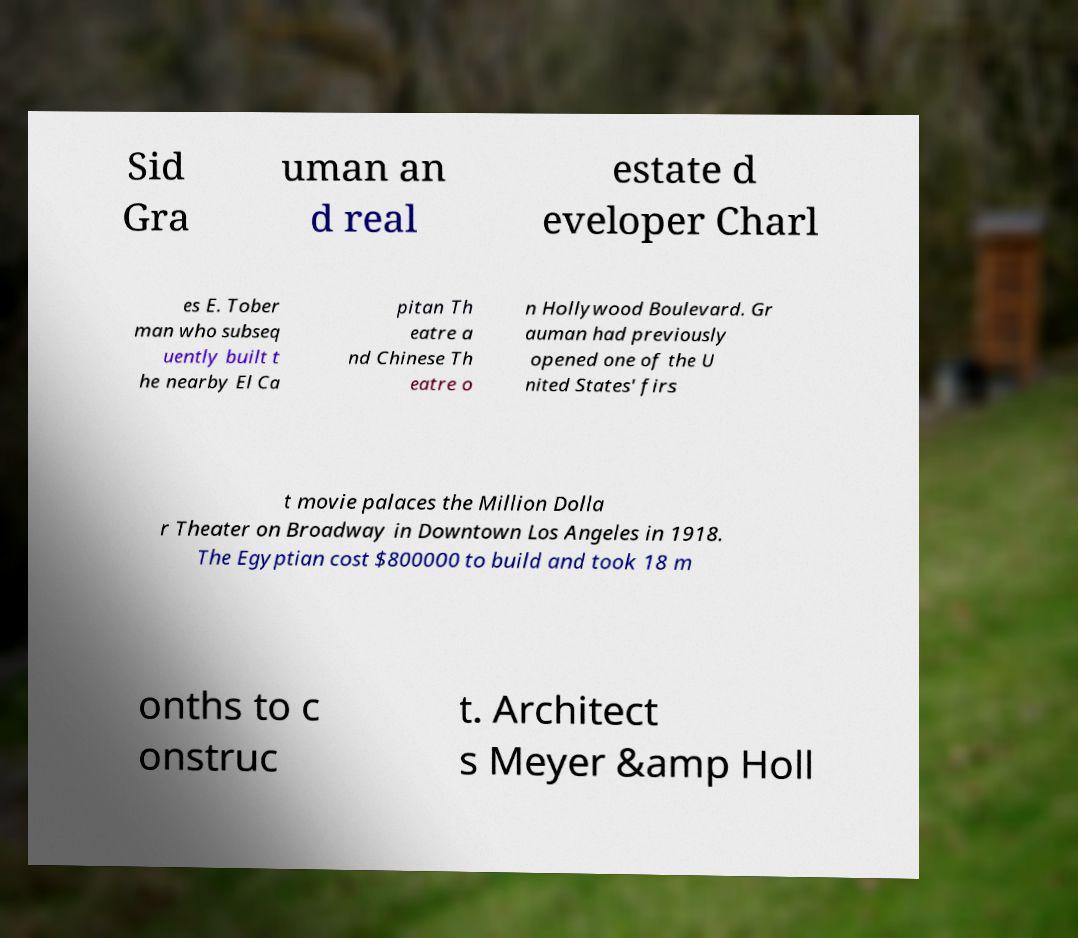Can you accurately transcribe the text from the provided image for me? Sid Gra uman an d real estate d eveloper Charl es E. Tober man who subseq uently built t he nearby El Ca pitan Th eatre a nd Chinese Th eatre o n Hollywood Boulevard. Gr auman had previously opened one of the U nited States' firs t movie palaces the Million Dolla r Theater on Broadway in Downtown Los Angeles in 1918. The Egyptian cost $800000 to build and took 18 m onths to c onstruc t. Architect s Meyer &amp Holl 